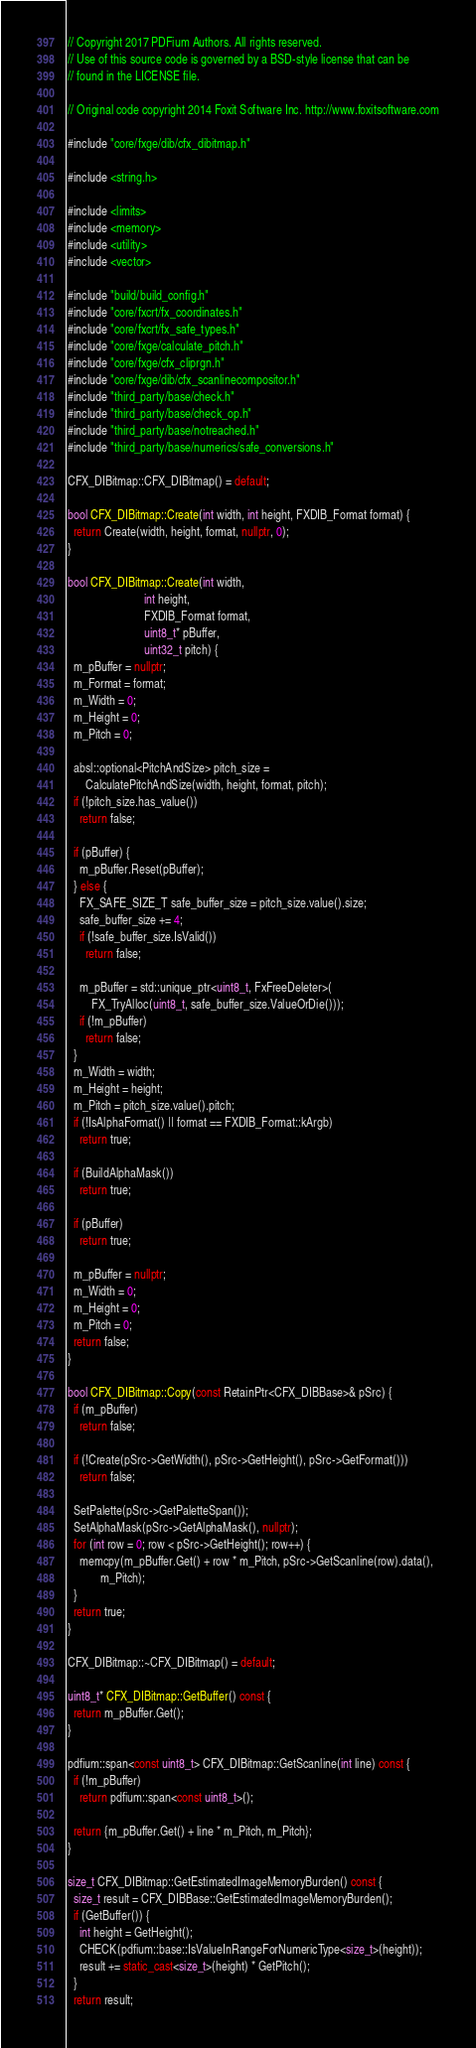<code> <loc_0><loc_0><loc_500><loc_500><_C++_>// Copyright 2017 PDFium Authors. All rights reserved.
// Use of this source code is governed by a BSD-style license that can be
// found in the LICENSE file.

// Original code copyright 2014 Foxit Software Inc. http://www.foxitsoftware.com

#include "core/fxge/dib/cfx_dibitmap.h"

#include <string.h>

#include <limits>
#include <memory>
#include <utility>
#include <vector>

#include "build/build_config.h"
#include "core/fxcrt/fx_coordinates.h"
#include "core/fxcrt/fx_safe_types.h"
#include "core/fxge/calculate_pitch.h"
#include "core/fxge/cfx_cliprgn.h"
#include "core/fxge/dib/cfx_scanlinecompositor.h"
#include "third_party/base/check.h"
#include "third_party/base/check_op.h"
#include "third_party/base/notreached.h"
#include "third_party/base/numerics/safe_conversions.h"

CFX_DIBitmap::CFX_DIBitmap() = default;

bool CFX_DIBitmap::Create(int width, int height, FXDIB_Format format) {
  return Create(width, height, format, nullptr, 0);
}

bool CFX_DIBitmap::Create(int width,
                          int height,
                          FXDIB_Format format,
                          uint8_t* pBuffer,
                          uint32_t pitch) {
  m_pBuffer = nullptr;
  m_Format = format;
  m_Width = 0;
  m_Height = 0;
  m_Pitch = 0;

  absl::optional<PitchAndSize> pitch_size =
      CalculatePitchAndSize(width, height, format, pitch);
  if (!pitch_size.has_value())
    return false;

  if (pBuffer) {
    m_pBuffer.Reset(pBuffer);
  } else {
    FX_SAFE_SIZE_T safe_buffer_size = pitch_size.value().size;
    safe_buffer_size += 4;
    if (!safe_buffer_size.IsValid())
      return false;

    m_pBuffer = std::unique_ptr<uint8_t, FxFreeDeleter>(
        FX_TryAlloc(uint8_t, safe_buffer_size.ValueOrDie()));
    if (!m_pBuffer)
      return false;
  }
  m_Width = width;
  m_Height = height;
  m_Pitch = pitch_size.value().pitch;
  if (!IsAlphaFormat() || format == FXDIB_Format::kArgb)
    return true;

  if (BuildAlphaMask())
    return true;

  if (pBuffer)
    return true;

  m_pBuffer = nullptr;
  m_Width = 0;
  m_Height = 0;
  m_Pitch = 0;
  return false;
}

bool CFX_DIBitmap::Copy(const RetainPtr<CFX_DIBBase>& pSrc) {
  if (m_pBuffer)
    return false;

  if (!Create(pSrc->GetWidth(), pSrc->GetHeight(), pSrc->GetFormat()))
    return false;

  SetPalette(pSrc->GetPaletteSpan());
  SetAlphaMask(pSrc->GetAlphaMask(), nullptr);
  for (int row = 0; row < pSrc->GetHeight(); row++) {
    memcpy(m_pBuffer.Get() + row * m_Pitch, pSrc->GetScanline(row).data(),
           m_Pitch);
  }
  return true;
}

CFX_DIBitmap::~CFX_DIBitmap() = default;

uint8_t* CFX_DIBitmap::GetBuffer() const {
  return m_pBuffer.Get();
}

pdfium::span<const uint8_t> CFX_DIBitmap::GetScanline(int line) const {
  if (!m_pBuffer)
    return pdfium::span<const uint8_t>();

  return {m_pBuffer.Get() + line * m_Pitch, m_Pitch};
}

size_t CFX_DIBitmap::GetEstimatedImageMemoryBurden() const {
  size_t result = CFX_DIBBase::GetEstimatedImageMemoryBurden();
  if (GetBuffer()) {
    int height = GetHeight();
    CHECK(pdfium::base::IsValueInRangeForNumericType<size_t>(height));
    result += static_cast<size_t>(height) * GetPitch();
  }
  return result;</code> 